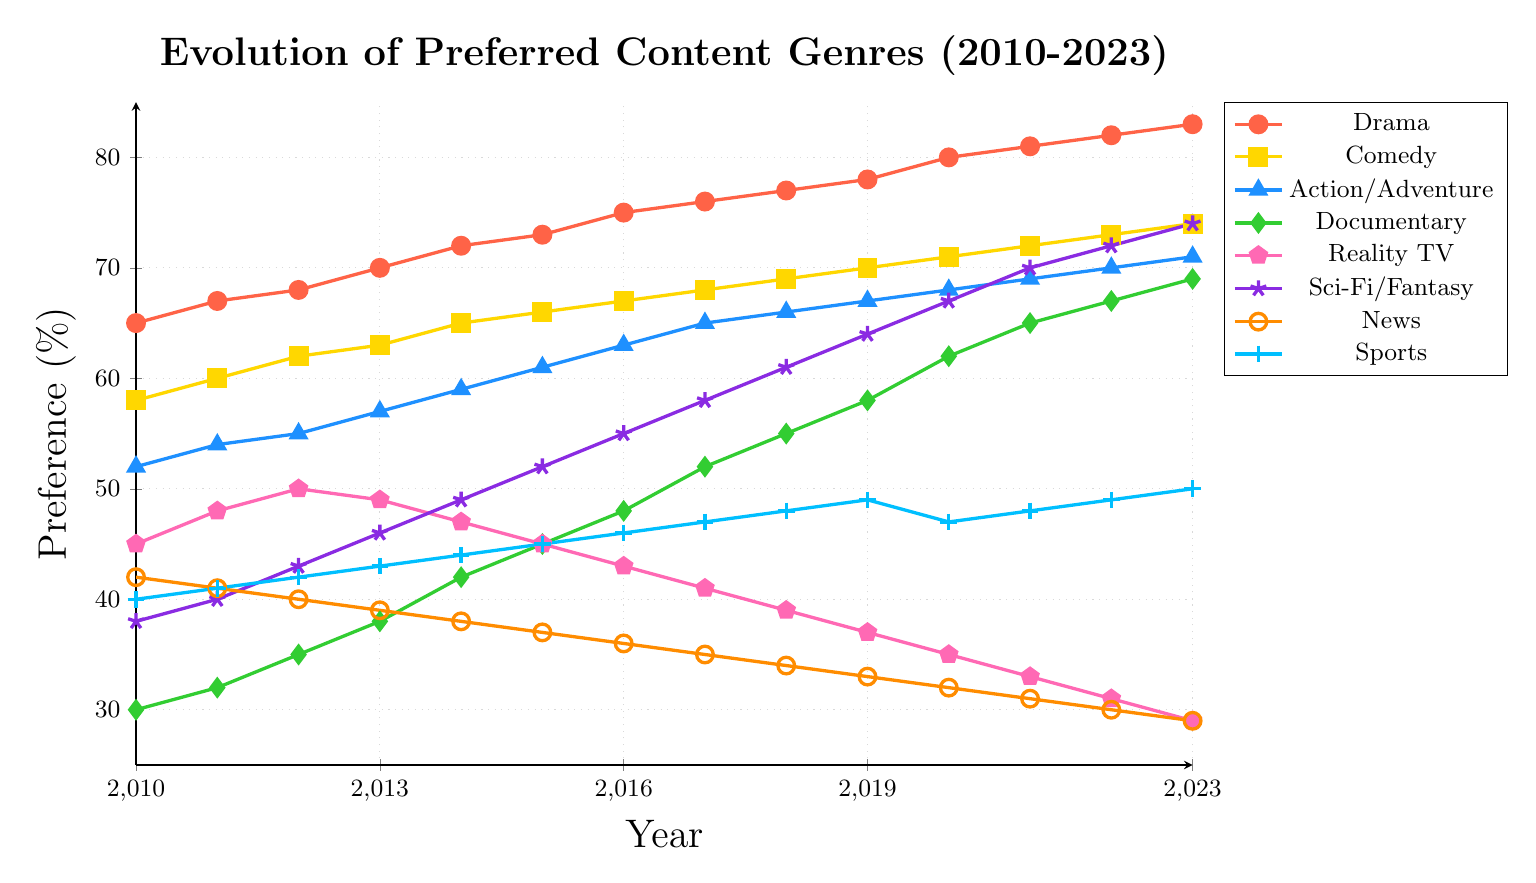Which content genre had the highest preference percentage in 2023? To find the genre with the highest preference, look at the values for 2023 and identify the highest one. Drama has the highest value with 83%.
Answer: Drama Which genre's preference increased the most from 2010 to 2023? Calculate the difference in preference for each genre between 2010 and 2023, then compare them. Drama increased from 65% to 83%, a difference of 18%, which is the largest increase.
Answer: Drama What is the general trend in preference for Reality TV from 2010 to 2023? Observe the progression of the line for Reality TV from 2010 to 2023. The line shows a decreasing trend, starting at 45% in 2010 and dropping to 29% in 2023.
Answer: Decreasing By how many percentage points did the preference for Documentaries increase between 2015 and 2023? Subtract the 2015 value from the 2023 value for Documentaries. The values are 45% and 69% respectively, resulting in an increase of 24 percentage points.
Answer: 24 Is the preference for News higher than the preference for Sports in 2013? Compare the 2013 values for News and Sports. News has 39% and Sports has 43%, so News is not higher than Sports.
Answer: No Which genre had a steady increase throughout the years 2010 to 2023? Look at each genre and see if the trend line is consistently increasing. Comedy increases steadily from 58% in 2010 to 74% in 2023.
Answer: Comedy In what year did Sci-Fi/Fantasy surpass Documentary in preference? Identify the year where the value for Sci-Fi/Fantasy becomes higher than that for Documentary for the first time. This transition happens around 2018 when Sci-Fi/Fantasy is at 61% and Documentary is at 55%.
Answer: 2018 What is the average preference for Sports from 2010 to 2023? Add up all the values of preference for Sports from 2010 to 2023 and divide by the number of years (14). The sum of values is 631 (40 + 41 + 42 + 43 + 44 + 45 + 46 + 47 + 48 + 49 + 47 + 48 + 49 + 50), so the average is 631 / 14 ≈ 45.07.
Answer: 45.07 Which had a larger preference in 2015, Action/Adventure or News? Look at the data points for 2015 for both genres. Action/Adventure is at 61% and News is at 37%. Thus, Action/Adventure had a larger preference.
Answer: Action/Adventure Does the genre Sports show any periods of decline from 2010 to 2023? Observe the trend line for Sports from 2010 to 2023. There is a slight decline between 2019 and 2020 (49% to 47%), but generally, it has an upward trend.
Answer: Yes 